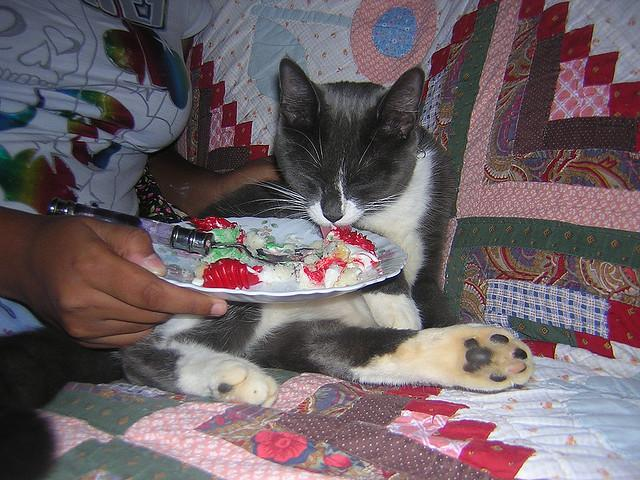How many toes does cats are supposed to have? Please explain your reasoning. 18. They have 6 on each foot. 